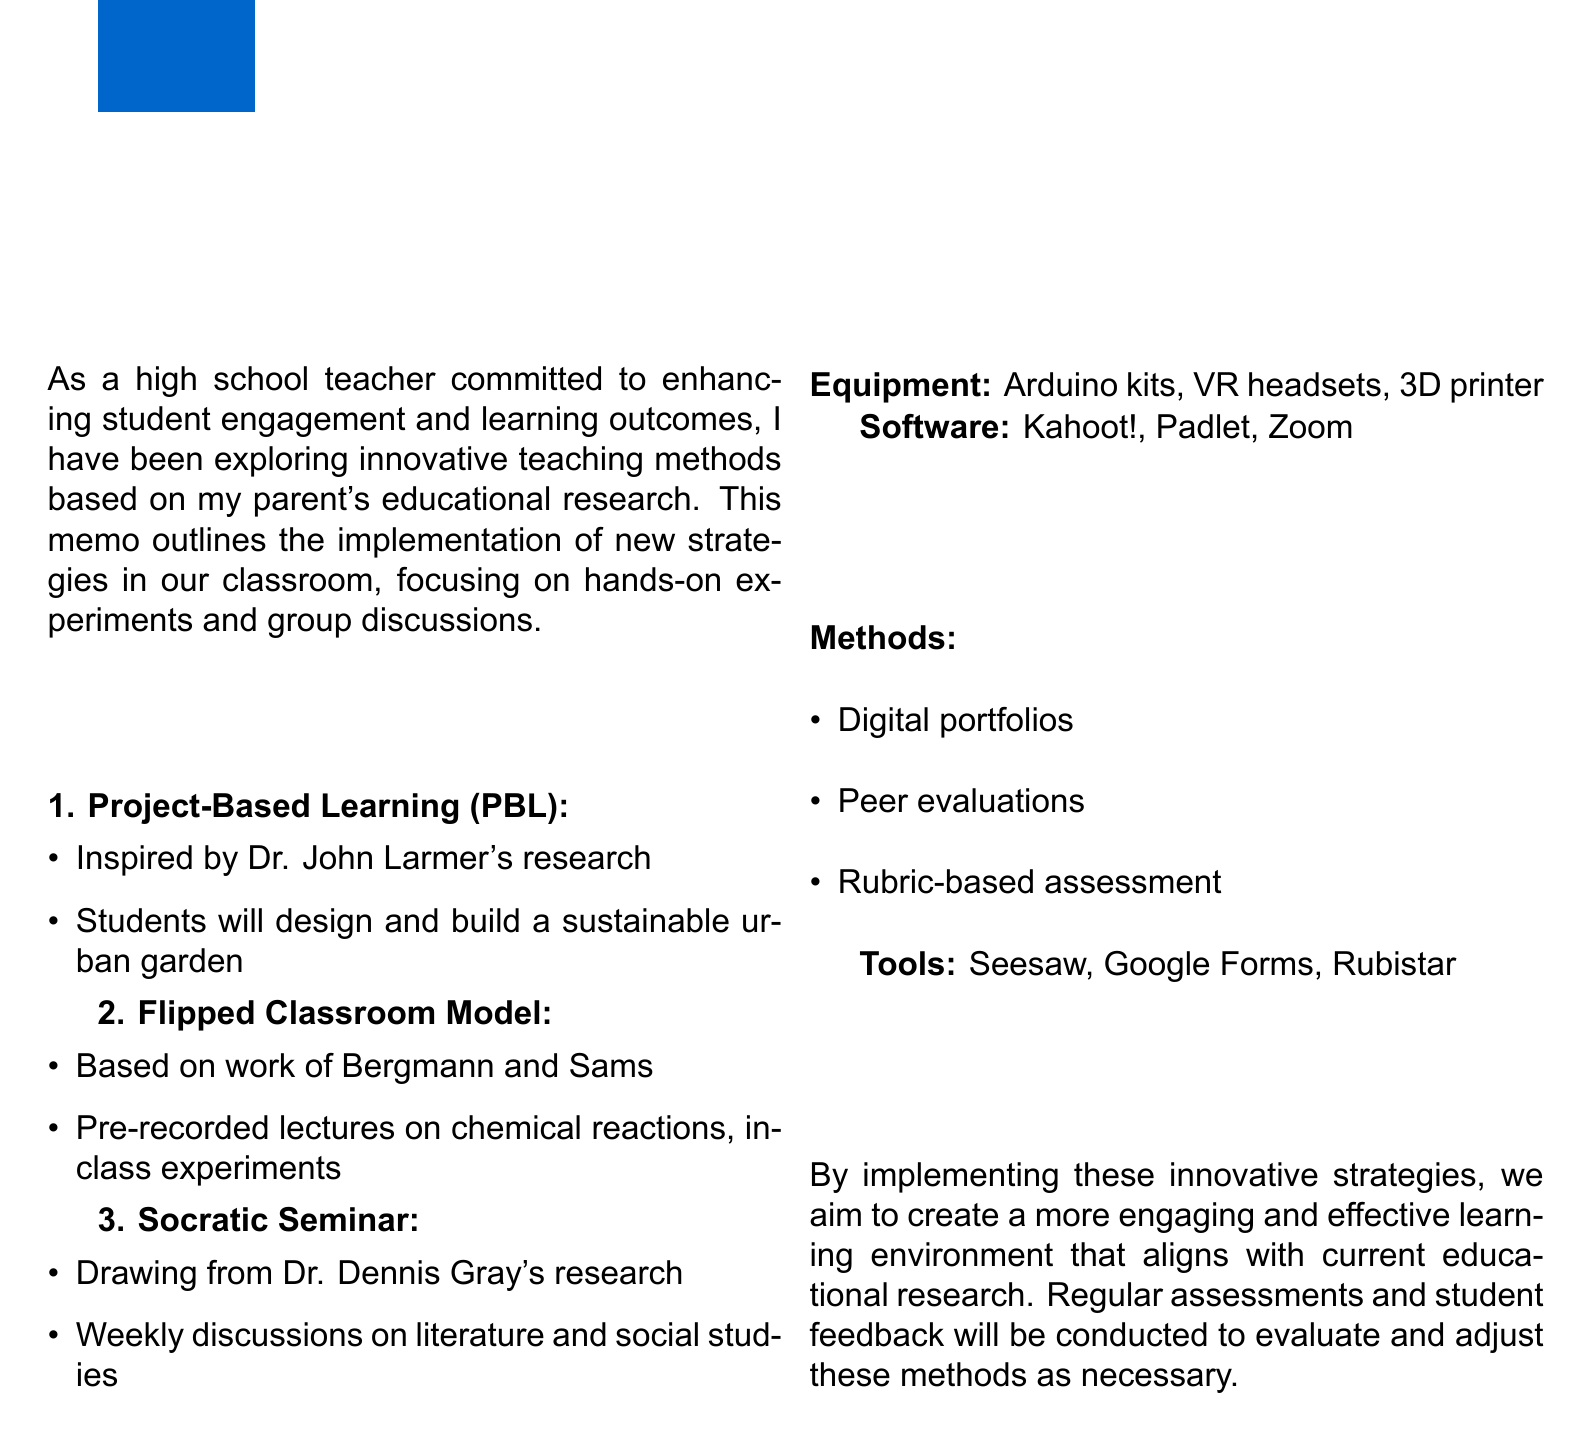What is the title of the memo? The title is provided at the top of the document as the memo's central theme.
Answer: Implementing Innovative Teaching Strategies Inspired by Parent's Research Who is the memo inspired by? The introduction states that the strategies are based on educational research conducted by a specific individual.
Answer: Parent What strategy involves a sustainable urban garden? The section on strategies describes specific educational methods that may involve practical implementation.
Answer: Project-Based Learning (PBL) What is one of the software resources mentioned? The resources section lists various software tools utilized in the classroom for different educational purposes.
Answer: Kahoot! How will students showcase their projects? The assessment section indicates methods for evaluating student projects, highlighting how students can present their work.
Answer: Digital portfolios How often will Socratic seminars be held? The implementation plan for the Socratic Seminar strategy specifies the frequency of these discussions.
Answer: Weekly What assessment tool is used for peer evaluations? The assessment section mentions various tools for conducting evaluations, including a specific platform.
Answer: Google Forms What is the main focus of the memo? The introductory part outlines the primary goal of these innovative teaching methods in relation to student learning.
Answer: Hands-on experiments and group discussions What color is the primary theme used in the document? The styling of the document indicates a specific color scheme tied to the visual presentation of the memo.
Answer: Blue 